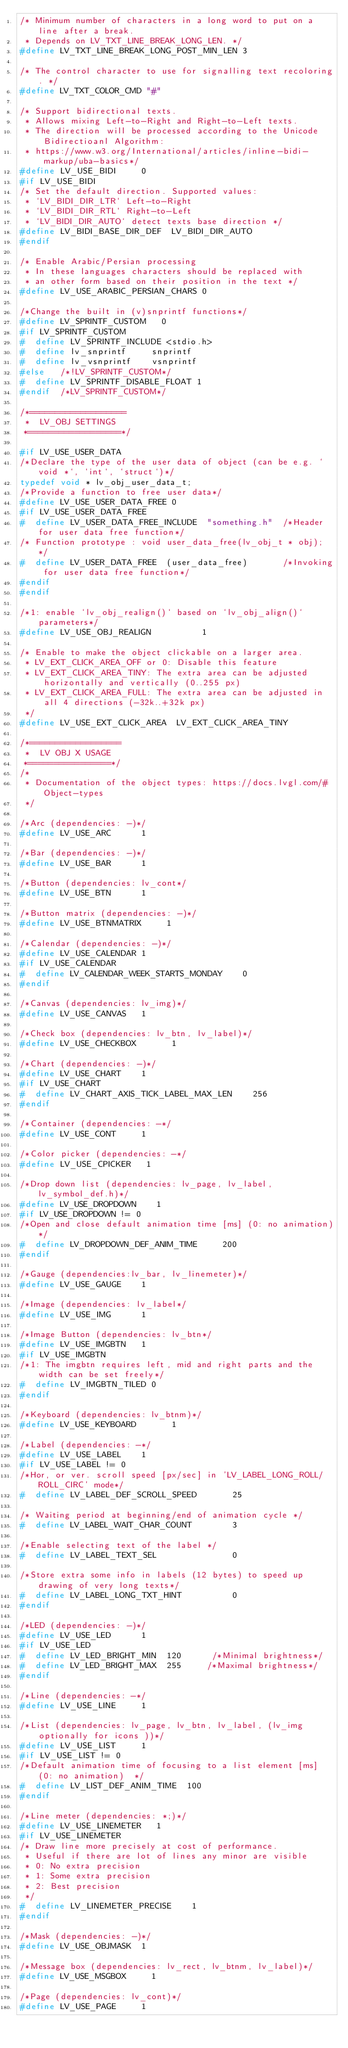Convert code to text. <code><loc_0><loc_0><loc_500><loc_500><_C_>/* Minimum number of characters in a long word to put on a line after a break.
 * Depends on LV_TXT_LINE_BREAK_LONG_LEN. */
#define LV_TXT_LINE_BREAK_LONG_POST_MIN_LEN 3

/* The control character to use for signalling text recoloring. */
#define LV_TXT_COLOR_CMD "#"

/* Support bidirectional texts.
 * Allows mixing Left-to-Right and Right-to-Left texts.
 * The direction will be processed according to the Unicode Bidirectioanl Algorithm:
 * https://www.w3.org/International/articles/inline-bidi-markup/uba-basics*/
#define LV_USE_BIDI     0
#if LV_USE_BIDI
/* Set the default direction. Supported values:
 * `LV_BIDI_DIR_LTR` Left-to-Right
 * `LV_BIDI_DIR_RTL` Right-to-Left
 * `LV_BIDI_DIR_AUTO` detect texts base direction */
#define LV_BIDI_BASE_DIR_DEF  LV_BIDI_DIR_AUTO
#endif

/* Enable Arabic/Persian processing
 * In these languages characters should be replaced with
 * an other form based on their position in the text */
#define LV_USE_ARABIC_PERSIAN_CHARS 0

/*Change the built in (v)snprintf functions*/
#define LV_SPRINTF_CUSTOM   0
#if LV_SPRINTF_CUSTOM
#  define LV_SPRINTF_INCLUDE <stdio.h>
#  define lv_snprintf     snprintf
#  define lv_vsnprintf    vsnprintf
#else   /*!LV_SPRINTF_CUSTOM*/
#  define LV_SPRINTF_DISABLE_FLOAT 1
#endif  /*LV_SPRINTF_CUSTOM*/

/*===================
 *  LV_OBJ SETTINGS
 *==================*/

#if LV_USE_USER_DATA
/*Declare the type of the user data of object (can be e.g. `void *`, `int`, `struct`)*/
typedef void * lv_obj_user_data_t;
/*Provide a function to free user data*/
#define LV_USE_USER_DATA_FREE 0
#if LV_USE_USER_DATA_FREE
#  define LV_USER_DATA_FREE_INCLUDE  "something.h"  /*Header for user data free function*/
/* Function prototype : void user_data_free(lv_obj_t * obj); */
#  define LV_USER_DATA_FREE  (user_data_free)       /*Invoking for user data free function*/
#endif
#endif

/*1: enable `lv_obj_realign()` based on `lv_obj_align()` parameters*/
#define LV_USE_OBJ_REALIGN          1

/* Enable to make the object clickable on a larger area.
 * LV_EXT_CLICK_AREA_OFF or 0: Disable this feature
 * LV_EXT_CLICK_AREA_TINY: The extra area can be adjusted horizontally and vertically (0..255 px)
 * LV_EXT_CLICK_AREA_FULL: The extra area can be adjusted in all 4 directions (-32k..+32k px)
 */
#define LV_USE_EXT_CLICK_AREA  LV_EXT_CLICK_AREA_TINY

/*==================
 *  LV OBJ X USAGE
 *================*/
/*
 * Documentation of the object types: https://docs.lvgl.com/#Object-types
 */

/*Arc (dependencies: -)*/
#define LV_USE_ARC      1

/*Bar (dependencies: -)*/
#define LV_USE_BAR      1

/*Button (dependencies: lv_cont*/
#define LV_USE_BTN      1

/*Button matrix (dependencies: -)*/
#define LV_USE_BTNMATRIX     1

/*Calendar (dependencies: -)*/
#define LV_USE_CALENDAR 1
#if LV_USE_CALENDAR
#  define LV_CALENDAR_WEEK_STARTS_MONDAY    0
#endif

/*Canvas (dependencies: lv_img)*/
#define LV_USE_CANVAS   1

/*Check box (dependencies: lv_btn, lv_label)*/
#define LV_USE_CHECKBOX       1

/*Chart (dependencies: -)*/
#define LV_USE_CHART    1
#if LV_USE_CHART
#  define LV_CHART_AXIS_TICK_LABEL_MAX_LEN    256
#endif

/*Container (dependencies: -*/
#define LV_USE_CONT     1

/*Color picker (dependencies: -*/
#define LV_USE_CPICKER   1

/*Drop down list (dependencies: lv_page, lv_label, lv_symbol_def.h)*/
#define LV_USE_DROPDOWN    1
#if LV_USE_DROPDOWN != 0
/*Open and close default animation time [ms] (0: no animation)*/
#  define LV_DROPDOWN_DEF_ANIM_TIME     200
#endif

/*Gauge (dependencies:lv_bar, lv_linemeter)*/
#define LV_USE_GAUGE    1

/*Image (dependencies: lv_label*/
#define LV_USE_IMG      1

/*Image Button (dependencies: lv_btn*/
#define LV_USE_IMGBTN   1
#if LV_USE_IMGBTN
/*1: The imgbtn requires left, mid and right parts and the width can be set freely*/
#  define LV_IMGBTN_TILED 0
#endif

/*Keyboard (dependencies: lv_btnm)*/
#define LV_USE_KEYBOARD       1

/*Label (dependencies: -*/
#define LV_USE_LABEL    1
#if LV_USE_LABEL != 0
/*Hor, or ver. scroll speed [px/sec] in 'LV_LABEL_LONG_ROLL/ROLL_CIRC' mode*/
#  define LV_LABEL_DEF_SCROLL_SPEED       25

/* Waiting period at beginning/end of animation cycle */
#  define LV_LABEL_WAIT_CHAR_COUNT        3

/*Enable selecting text of the label */
#  define LV_LABEL_TEXT_SEL               0

/*Store extra some info in labels (12 bytes) to speed up drawing of very long texts*/
#  define LV_LABEL_LONG_TXT_HINT          0
#endif

/*LED (dependencies: -)*/
#define LV_USE_LED      1
#if LV_USE_LED
#  define LV_LED_BRIGHT_MIN  120      /*Minimal brightness*/
#  define LV_LED_BRIGHT_MAX  255     /*Maximal brightness*/
#endif

/*Line (dependencies: -*/
#define LV_USE_LINE     1

/*List (dependencies: lv_page, lv_btn, lv_label, (lv_img optionally for icons ))*/
#define LV_USE_LIST     1
#if LV_USE_LIST != 0
/*Default animation time of focusing to a list element [ms] (0: no animation)  */
#  define LV_LIST_DEF_ANIM_TIME  100
#endif

/*Line meter (dependencies: *;)*/
#define LV_USE_LINEMETER   1
#if LV_USE_LINEMETER
/* Draw line more precisely at cost of performance.
 * Useful if there are lot of lines any minor are visible
 * 0: No extra precision
 * 1: Some extra precision
 * 2: Best precision
 */
#  define LV_LINEMETER_PRECISE    1
#endif

/*Mask (dependencies: -)*/
#define LV_USE_OBJMASK  1

/*Message box (dependencies: lv_rect, lv_btnm, lv_label)*/
#define LV_USE_MSGBOX     1

/*Page (dependencies: lv_cont)*/
#define LV_USE_PAGE     1</code> 